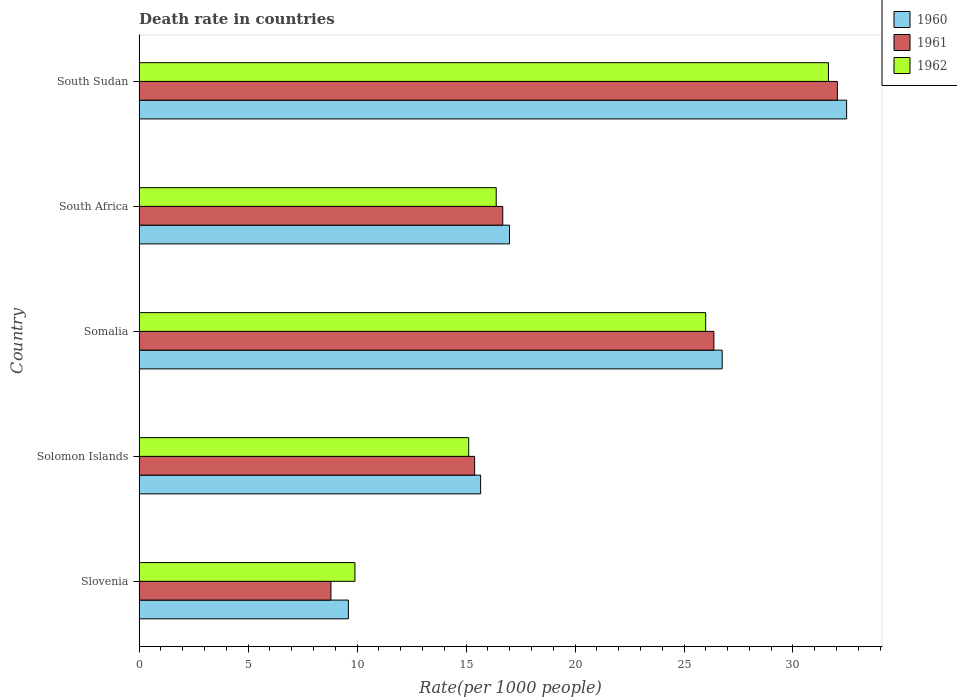How many different coloured bars are there?
Your answer should be very brief. 3. Are the number of bars per tick equal to the number of legend labels?
Ensure brevity in your answer.  Yes. How many bars are there on the 1st tick from the top?
Your answer should be compact. 3. What is the label of the 2nd group of bars from the top?
Ensure brevity in your answer.  South Africa. In how many cases, is the number of bars for a given country not equal to the number of legend labels?
Offer a very short reply. 0. What is the death rate in 1960 in South Africa?
Offer a very short reply. 16.99. Across all countries, what is the maximum death rate in 1962?
Provide a short and direct response. 31.63. Across all countries, what is the minimum death rate in 1961?
Your response must be concise. 8.8. In which country was the death rate in 1961 maximum?
Provide a short and direct response. South Sudan. In which country was the death rate in 1960 minimum?
Your answer should be compact. Slovenia. What is the total death rate in 1962 in the graph?
Ensure brevity in your answer.  99.02. What is the difference between the death rate in 1961 in Somalia and that in South Africa?
Ensure brevity in your answer.  9.69. What is the difference between the death rate in 1961 in South Africa and the death rate in 1962 in South Sudan?
Provide a succinct answer. -14.94. What is the average death rate in 1960 per country?
Make the answer very short. 20.29. What is the difference between the death rate in 1961 and death rate in 1960 in South Africa?
Your answer should be compact. -0.31. What is the ratio of the death rate in 1962 in Solomon Islands to that in Somalia?
Provide a short and direct response. 0.58. Is the death rate in 1962 in Solomon Islands less than that in South Africa?
Your answer should be very brief. Yes. Is the difference between the death rate in 1961 in Slovenia and South Africa greater than the difference between the death rate in 1960 in Slovenia and South Africa?
Ensure brevity in your answer.  No. What is the difference between the highest and the second highest death rate in 1962?
Your answer should be compact. 5.63. What is the difference between the highest and the lowest death rate in 1960?
Provide a succinct answer. 22.86. Is the sum of the death rate in 1960 in Solomon Islands and South Africa greater than the maximum death rate in 1961 across all countries?
Keep it short and to the point. Yes. What does the 2nd bar from the bottom in South Africa represents?
Your answer should be compact. 1961. Is it the case that in every country, the sum of the death rate in 1960 and death rate in 1962 is greater than the death rate in 1961?
Your answer should be compact. Yes. How many countries are there in the graph?
Give a very brief answer. 5. What is the difference between two consecutive major ticks on the X-axis?
Make the answer very short. 5. Does the graph contain any zero values?
Offer a terse response. No. Does the graph contain grids?
Offer a very short reply. No. Where does the legend appear in the graph?
Your answer should be compact. Top right. What is the title of the graph?
Offer a very short reply. Death rate in countries. Does "2002" appear as one of the legend labels in the graph?
Offer a terse response. No. What is the label or title of the X-axis?
Your response must be concise. Rate(per 1000 people). What is the label or title of the Y-axis?
Your response must be concise. Country. What is the Rate(per 1000 people) of 1962 in Slovenia?
Provide a short and direct response. 9.9. What is the Rate(per 1000 people) of 1960 in Solomon Islands?
Give a very brief answer. 15.67. What is the Rate(per 1000 people) of 1961 in Solomon Islands?
Offer a terse response. 15.39. What is the Rate(per 1000 people) of 1962 in Solomon Islands?
Make the answer very short. 15.12. What is the Rate(per 1000 people) of 1960 in Somalia?
Provide a short and direct response. 26.75. What is the Rate(per 1000 people) in 1961 in Somalia?
Offer a terse response. 26.37. What is the Rate(per 1000 people) in 1962 in Somalia?
Your answer should be compact. 25.99. What is the Rate(per 1000 people) in 1960 in South Africa?
Your answer should be compact. 16.99. What is the Rate(per 1000 people) in 1961 in South Africa?
Ensure brevity in your answer.  16.68. What is the Rate(per 1000 people) in 1962 in South Africa?
Offer a very short reply. 16.38. What is the Rate(per 1000 people) in 1960 in South Sudan?
Provide a short and direct response. 32.46. What is the Rate(per 1000 people) in 1961 in South Sudan?
Make the answer very short. 32.04. What is the Rate(per 1000 people) of 1962 in South Sudan?
Your response must be concise. 31.63. Across all countries, what is the maximum Rate(per 1000 people) of 1960?
Offer a terse response. 32.46. Across all countries, what is the maximum Rate(per 1000 people) of 1961?
Keep it short and to the point. 32.04. Across all countries, what is the maximum Rate(per 1000 people) in 1962?
Your response must be concise. 31.63. Across all countries, what is the minimum Rate(per 1000 people) in 1962?
Offer a very short reply. 9.9. What is the total Rate(per 1000 people) in 1960 in the graph?
Offer a very short reply. 101.47. What is the total Rate(per 1000 people) in 1961 in the graph?
Make the answer very short. 99.28. What is the total Rate(per 1000 people) in 1962 in the graph?
Make the answer very short. 99.03. What is the difference between the Rate(per 1000 people) of 1960 in Slovenia and that in Solomon Islands?
Provide a succinct answer. -6.07. What is the difference between the Rate(per 1000 people) of 1961 in Slovenia and that in Solomon Islands?
Provide a succinct answer. -6.59. What is the difference between the Rate(per 1000 people) of 1962 in Slovenia and that in Solomon Islands?
Keep it short and to the point. -5.22. What is the difference between the Rate(per 1000 people) of 1960 in Slovenia and that in Somalia?
Give a very brief answer. -17.15. What is the difference between the Rate(per 1000 people) of 1961 in Slovenia and that in Somalia?
Ensure brevity in your answer.  -17.57. What is the difference between the Rate(per 1000 people) of 1962 in Slovenia and that in Somalia?
Offer a very short reply. -16.09. What is the difference between the Rate(per 1000 people) of 1960 in Slovenia and that in South Africa?
Keep it short and to the point. -7.39. What is the difference between the Rate(per 1000 people) of 1961 in Slovenia and that in South Africa?
Provide a succinct answer. -7.88. What is the difference between the Rate(per 1000 people) in 1962 in Slovenia and that in South Africa?
Your response must be concise. -6.48. What is the difference between the Rate(per 1000 people) in 1960 in Slovenia and that in South Sudan?
Keep it short and to the point. -22.86. What is the difference between the Rate(per 1000 people) in 1961 in Slovenia and that in South Sudan?
Offer a very short reply. -23.24. What is the difference between the Rate(per 1000 people) in 1962 in Slovenia and that in South Sudan?
Your response must be concise. -21.73. What is the difference between the Rate(per 1000 people) in 1960 in Solomon Islands and that in Somalia?
Make the answer very short. -11.08. What is the difference between the Rate(per 1000 people) in 1961 in Solomon Islands and that in Somalia?
Offer a very short reply. -10.98. What is the difference between the Rate(per 1000 people) of 1962 in Solomon Islands and that in Somalia?
Your answer should be compact. -10.87. What is the difference between the Rate(per 1000 people) in 1960 in Solomon Islands and that in South Africa?
Your answer should be compact. -1.32. What is the difference between the Rate(per 1000 people) of 1961 in Solomon Islands and that in South Africa?
Give a very brief answer. -1.29. What is the difference between the Rate(per 1000 people) in 1962 in Solomon Islands and that in South Africa?
Offer a terse response. -1.26. What is the difference between the Rate(per 1000 people) in 1960 in Solomon Islands and that in South Sudan?
Keep it short and to the point. -16.79. What is the difference between the Rate(per 1000 people) in 1961 in Solomon Islands and that in South Sudan?
Your answer should be compact. -16.64. What is the difference between the Rate(per 1000 people) in 1962 in Solomon Islands and that in South Sudan?
Provide a short and direct response. -16.51. What is the difference between the Rate(per 1000 people) in 1960 in Somalia and that in South Africa?
Offer a very short reply. 9.76. What is the difference between the Rate(per 1000 people) of 1961 in Somalia and that in South Africa?
Ensure brevity in your answer.  9.69. What is the difference between the Rate(per 1000 people) in 1962 in Somalia and that in South Africa?
Offer a terse response. 9.61. What is the difference between the Rate(per 1000 people) of 1960 in Somalia and that in South Sudan?
Offer a very short reply. -5.71. What is the difference between the Rate(per 1000 people) of 1961 in Somalia and that in South Sudan?
Provide a succinct answer. -5.67. What is the difference between the Rate(per 1000 people) in 1962 in Somalia and that in South Sudan?
Your answer should be very brief. -5.63. What is the difference between the Rate(per 1000 people) of 1960 in South Africa and that in South Sudan?
Make the answer very short. -15.47. What is the difference between the Rate(per 1000 people) in 1961 in South Africa and that in South Sudan?
Offer a very short reply. -15.35. What is the difference between the Rate(per 1000 people) of 1962 in South Africa and that in South Sudan?
Ensure brevity in your answer.  -15.24. What is the difference between the Rate(per 1000 people) of 1960 in Slovenia and the Rate(per 1000 people) of 1961 in Solomon Islands?
Make the answer very short. -5.79. What is the difference between the Rate(per 1000 people) of 1960 in Slovenia and the Rate(per 1000 people) of 1962 in Solomon Islands?
Provide a short and direct response. -5.52. What is the difference between the Rate(per 1000 people) in 1961 in Slovenia and the Rate(per 1000 people) in 1962 in Solomon Islands?
Provide a short and direct response. -6.32. What is the difference between the Rate(per 1000 people) in 1960 in Slovenia and the Rate(per 1000 people) in 1961 in Somalia?
Ensure brevity in your answer.  -16.77. What is the difference between the Rate(per 1000 people) in 1960 in Slovenia and the Rate(per 1000 people) in 1962 in Somalia?
Keep it short and to the point. -16.39. What is the difference between the Rate(per 1000 people) in 1961 in Slovenia and the Rate(per 1000 people) in 1962 in Somalia?
Your response must be concise. -17.19. What is the difference between the Rate(per 1000 people) of 1960 in Slovenia and the Rate(per 1000 people) of 1961 in South Africa?
Make the answer very short. -7.08. What is the difference between the Rate(per 1000 people) of 1960 in Slovenia and the Rate(per 1000 people) of 1962 in South Africa?
Offer a very short reply. -6.78. What is the difference between the Rate(per 1000 people) of 1961 in Slovenia and the Rate(per 1000 people) of 1962 in South Africa?
Offer a very short reply. -7.58. What is the difference between the Rate(per 1000 people) of 1960 in Slovenia and the Rate(per 1000 people) of 1961 in South Sudan?
Provide a short and direct response. -22.44. What is the difference between the Rate(per 1000 people) in 1960 in Slovenia and the Rate(per 1000 people) in 1962 in South Sudan?
Make the answer very short. -22.03. What is the difference between the Rate(per 1000 people) in 1961 in Slovenia and the Rate(per 1000 people) in 1962 in South Sudan?
Your answer should be compact. -22.83. What is the difference between the Rate(per 1000 people) in 1960 in Solomon Islands and the Rate(per 1000 people) in 1961 in Somalia?
Your answer should be compact. -10.7. What is the difference between the Rate(per 1000 people) of 1960 in Solomon Islands and the Rate(per 1000 people) of 1962 in Somalia?
Offer a very short reply. -10.33. What is the difference between the Rate(per 1000 people) of 1961 in Solomon Islands and the Rate(per 1000 people) of 1962 in Somalia?
Ensure brevity in your answer.  -10.6. What is the difference between the Rate(per 1000 people) of 1960 in Solomon Islands and the Rate(per 1000 people) of 1961 in South Africa?
Make the answer very short. -1.01. What is the difference between the Rate(per 1000 people) in 1960 in Solomon Islands and the Rate(per 1000 people) in 1962 in South Africa?
Provide a succinct answer. -0.71. What is the difference between the Rate(per 1000 people) in 1961 in Solomon Islands and the Rate(per 1000 people) in 1962 in South Africa?
Give a very brief answer. -0.99. What is the difference between the Rate(per 1000 people) in 1960 in Solomon Islands and the Rate(per 1000 people) in 1961 in South Sudan?
Offer a terse response. -16.37. What is the difference between the Rate(per 1000 people) in 1960 in Solomon Islands and the Rate(per 1000 people) in 1962 in South Sudan?
Your answer should be very brief. -15.96. What is the difference between the Rate(per 1000 people) in 1961 in Solomon Islands and the Rate(per 1000 people) in 1962 in South Sudan?
Provide a short and direct response. -16.23. What is the difference between the Rate(per 1000 people) of 1960 in Somalia and the Rate(per 1000 people) of 1961 in South Africa?
Provide a succinct answer. 10.07. What is the difference between the Rate(per 1000 people) in 1960 in Somalia and the Rate(per 1000 people) in 1962 in South Africa?
Make the answer very short. 10.37. What is the difference between the Rate(per 1000 people) of 1961 in Somalia and the Rate(per 1000 people) of 1962 in South Africa?
Make the answer very short. 9.99. What is the difference between the Rate(per 1000 people) in 1960 in Somalia and the Rate(per 1000 people) in 1961 in South Sudan?
Your response must be concise. -5.29. What is the difference between the Rate(per 1000 people) in 1960 in Somalia and the Rate(per 1000 people) in 1962 in South Sudan?
Give a very brief answer. -4.88. What is the difference between the Rate(per 1000 people) in 1961 in Somalia and the Rate(per 1000 people) in 1962 in South Sudan?
Your answer should be very brief. -5.26. What is the difference between the Rate(per 1000 people) in 1960 in South Africa and the Rate(per 1000 people) in 1961 in South Sudan?
Make the answer very short. -15.04. What is the difference between the Rate(per 1000 people) in 1960 in South Africa and the Rate(per 1000 people) in 1962 in South Sudan?
Ensure brevity in your answer.  -14.63. What is the difference between the Rate(per 1000 people) in 1961 in South Africa and the Rate(per 1000 people) in 1962 in South Sudan?
Make the answer very short. -14.94. What is the average Rate(per 1000 people) in 1960 per country?
Ensure brevity in your answer.  20.29. What is the average Rate(per 1000 people) of 1961 per country?
Your answer should be compact. 19.86. What is the average Rate(per 1000 people) of 1962 per country?
Ensure brevity in your answer.  19.8. What is the difference between the Rate(per 1000 people) of 1960 and Rate(per 1000 people) of 1961 in Slovenia?
Make the answer very short. 0.8. What is the difference between the Rate(per 1000 people) of 1960 and Rate(per 1000 people) of 1962 in Slovenia?
Your response must be concise. -0.3. What is the difference between the Rate(per 1000 people) in 1961 and Rate(per 1000 people) in 1962 in Slovenia?
Keep it short and to the point. -1.1. What is the difference between the Rate(per 1000 people) in 1960 and Rate(per 1000 people) in 1961 in Solomon Islands?
Ensure brevity in your answer.  0.28. What is the difference between the Rate(per 1000 people) in 1960 and Rate(per 1000 people) in 1962 in Solomon Islands?
Offer a very short reply. 0.55. What is the difference between the Rate(per 1000 people) of 1961 and Rate(per 1000 people) of 1962 in Solomon Islands?
Keep it short and to the point. 0.27. What is the difference between the Rate(per 1000 people) of 1960 and Rate(per 1000 people) of 1961 in Somalia?
Offer a terse response. 0.38. What is the difference between the Rate(per 1000 people) in 1960 and Rate(per 1000 people) in 1962 in Somalia?
Your answer should be very brief. 0.76. What is the difference between the Rate(per 1000 people) of 1961 and Rate(per 1000 people) of 1962 in Somalia?
Offer a terse response. 0.38. What is the difference between the Rate(per 1000 people) of 1960 and Rate(per 1000 people) of 1961 in South Africa?
Ensure brevity in your answer.  0.31. What is the difference between the Rate(per 1000 people) in 1960 and Rate(per 1000 people) in 1962 in South Africa?
Provide a succinct answer. 0.61. What is the difference between the Rate(per 1000 people) of 1960 and Rate(per 1000 people) of 1961 in South Sudan?
Your response must be concise. 0.42. What is the difference between the Rate(per 1000 people) in 1960 and Rate(per 1000 people) in 1962 in South Sudan?
Offer a terse response. 0.83. What is the difference between the Rate(per 1000 people) of 1961 and Rate(per 1000 people) of 1962 in South Sudan?
Offer a terse response. 0.41. What is the ratio of the Rate(per 1000 people) of 1960 in Slovenia to that in Solomon Islands?
Provide a succinct answer. 0.61. What is the ratio of the Rate(per 1000 people) in 1961 in Slovenia to that in Solomon Islands?
Ensure brevity in your answer.  0.57. What is the ratio of the Rate(per 1000 people) in 1962 in Slovenia to that in Solomon Islands?
Ensure brevity in your answer.  0.65. What is the ratio of the Rate(per 1000 people) in 1960 in Slovenia to that in Somalia?
Provide a short and direct response. 0.36. What is the ratio of the Rate(per 1000 people) in 1961 in Slovenia to that in Somalia?
Make the answer very short. 0.33. What is the ratio of the Rate(per 1000 people) of 1962 in Slovenia to that in Somalia?
Give a very brief answer. 0.38. What is the ratio of the Rate(per 1000 people) in 1960 in Slovenia to that in South Africa?
Offer a very short reply. 0.56. What is the ratio of the Rate(per 1000 people) of 1961 in Slovenia to that in South Africa?
Ensure brevity in your answer.  0.53. What is the ratio of the Rate(per 1000 people) of 1962 in Slovenia to that in South Africa?
Provide a succinct answer. 0.6. What is the ratio of the Rate(per 1000 people) of 1960 in Slovenia to that in South Sudan?
Your answer should be compact. 0.3. What is the ratio of the Rate(per 1000 people) in 1961 in Slovenia to that in South Sudan?
Provide a succinct answer. 0.27. What is the ratio of the Rate(per 1000 people) in 1962 in Slovenia to that in South Sudan?
Your response must be concise. 0.31. What is the ratio of the Rate(per 1000 people) in 1960 in Solomon Islands to that in Somalia?
Provide a succinct answer. 0.59. What is the ratio of the Rate(per 1000 people) of 1961 in Solomon Islands to that in Somalia?
Provide a short and direct response. 0.58. What is the ratio of the Rate(per 1000 people) of 1962 in Solomon Islands to that in Somalia?
Your answer should be compact. 0.58. What is the ratio of the Rate(per 1000 people) of 1960 in Solomon Islands to that in South Africa?
Provide a succinct answer. 0.92. What is the ratio of the Rate(per 1000 people) in 1961 in Solomon Islands to that in South Africa?
Give a very brief answer. 0.92. What is the ratio of the Rate(per 1000 people) in 1962 in Solomon Islands to that in South Africa?
Provide a short and direct response. 0.92. What is the ratio of the Rate(per 1000 people) in 1960 in Solomon Islands to that in South Sudan?
Provide a succinct answer. 0.48. What is the ratio of the Rate(per 1000 people) of 1961 in Solomon Islands to that in South Sudan?
Offer a very short reply. 0.48. What is the ratio of the Rate(per 1000 people) of 1962 in Solomon Islands to that in South Sudan?
Offer a terse response. 0.48. What is the ratio of the Rate(per 1000 people) in 1960 in Somalia to that in South Africa?
Keep it short and to the point. 1.57. What is the ratio of the Rate(per 1000 people) in 1961 in Somalia to that in South Africa?
Provide a short and direct response. 1.58. What is the ratio of the Rate(per 1000 people) in 1962 in Somalia to that in South Africa?
Give a very brief answer. 1.59. What is the ratio of the Rate(per 1000 people) of 1960 in Somalia to that in South Sudan?
Ensure brevity in your answer.  0.82. What is the ratio of the Rate(per 1000 people) in 1961 in Somalia to that in South Sudan?
Offer a very short reply. 0.82. What is the ratio of the Rate(per 1000 people) in 1962 in Somalia to that in South Sudan?
Offer a very short reply. 0.82. What is the ratio of the Rate(per 1000 people) of 1960 in South Africa to that in South Sudan?
Provide a succinct answer. 0.52. What is the ratio of the Rate(per 1000 people) in 1961 in South Africa to that in South Sudan?
Your answer should be very brief. 0.52. What is the ratio of the Rate(per 1000 people) in 1962 in South Africa to that in South Sudan?
Offer a very short reply. 0.52. What is the difference between the highest and the second highest Rate(per 1000 people) of 1960?
Give a very brief answer. 5.71. What is the difference between the highest and the second highest Rate(per 1000 people) in 1961?
Your answer should be very brief. 5.67. What is the difference between the highest and the second highest Rate(per 1000 people) in 1962?
Give a very brief answer. 5.63. What is the difference between the highest and the lowest Rate(per 1000 people) in 1960?
Your answer should be compact. 22.86. What is the difference between the highest and the lowest Rate(per 1000 people) of 1961?
Offer a very short reply. 23.24. What is the difference between the highest and the lowest Rate(per 1000 people) in 1962?
Make the answer very short. 21.73. 